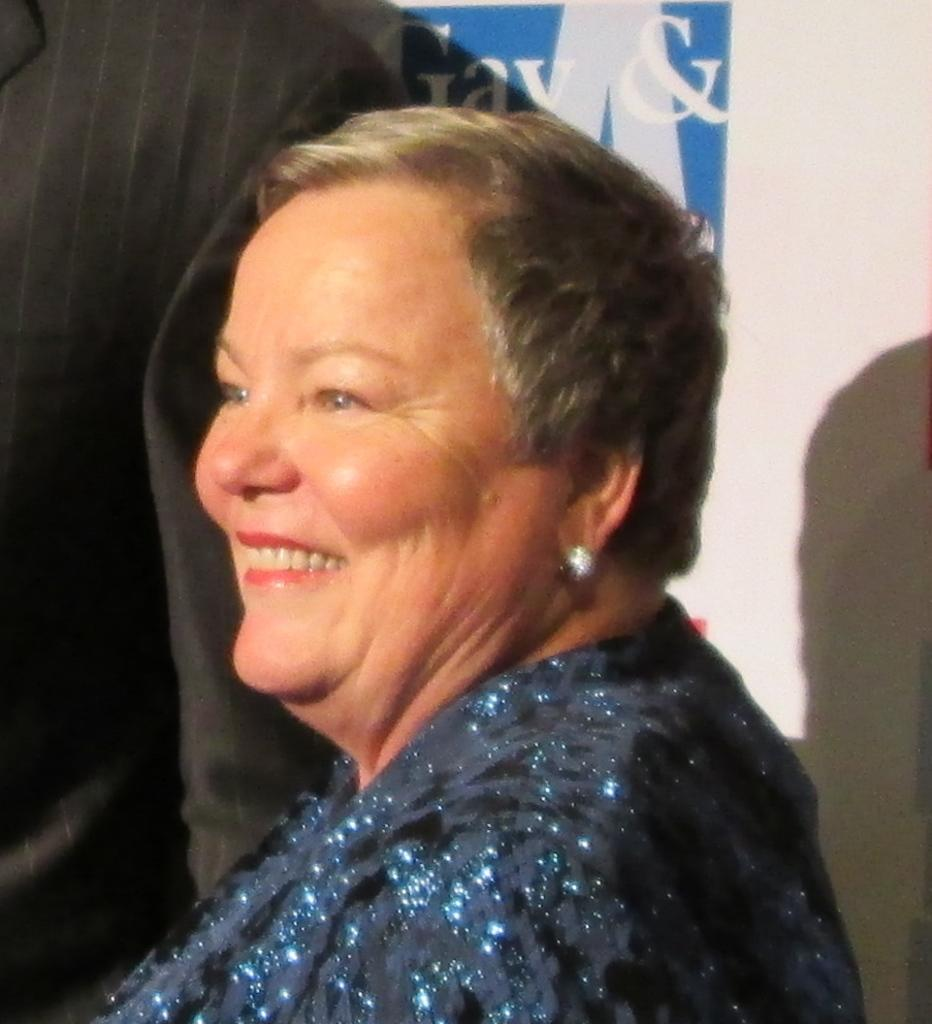Who is the main subject in the image? There is a woman in the image. What is the woman's facial expression? The woman is smiling. What is the woman wearing in the image? The woman is wearing a dress and earrings. What type of sugar is the woman using to sweeten her coffee in the image? There is no coffee or sugar present in the image; the woman is simply smiling and wearing a dress and earrings. 